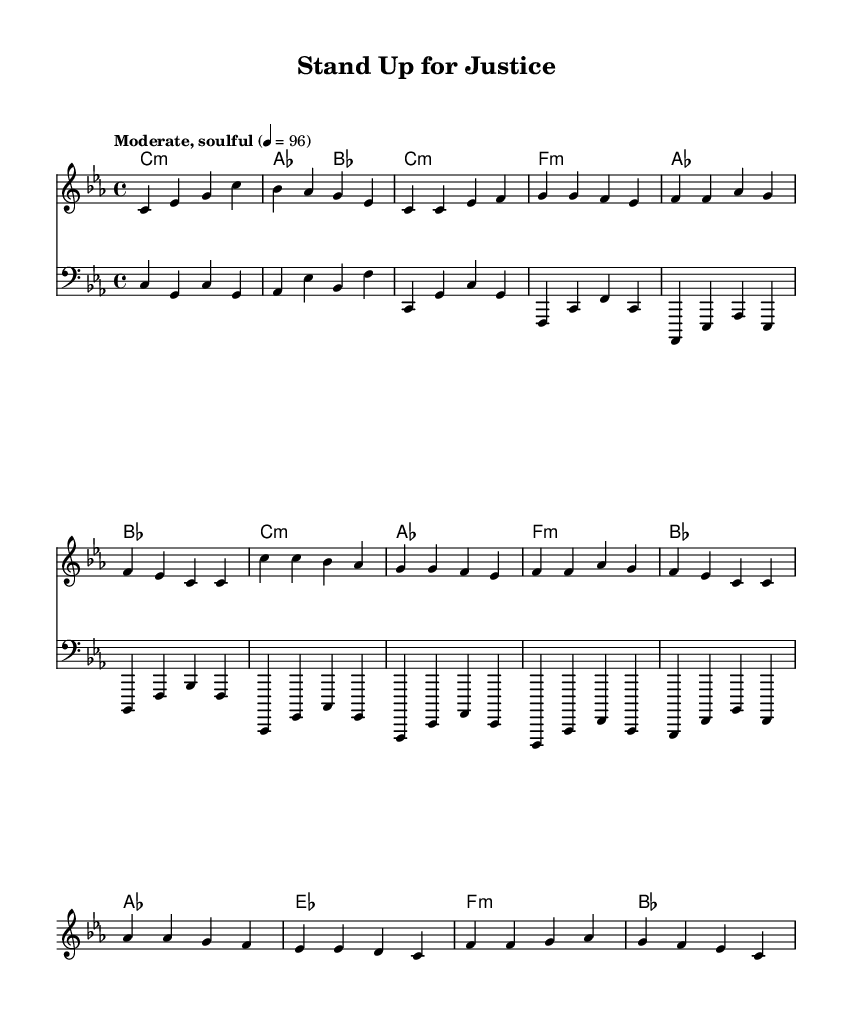What is the key signature of this music? The key signature is C minor, which has three flats (B♭, E♭, and A♭). This can be identified by the 'C' at the beginning of the 'global' section, followed by 'minor,' indicating the specific key.
Answer: C minor What is the time signature of this music? The time signature is 4/4, which is indicated at the beginning of the 'global' section with the 'time' command. In 4/4 time, there are four beats per measure, and the quarter note gets one beat.
Answer: 4/4 What is the tempo marking for this piece? The tempo marking is "Moderate, soulful," which is mentioned in the 'global' section, providing insight into the intended character and pace of the performance.
Answer: Moderate, soulful How many measures are in the verse? The verse consists of 8 measures, which can be counted by looking at the sections in the 'melody' part where the verse lyrics are set and separating them by bars.
Answer: 8 What is the main message conveyed in the chorus? The main message in the chorus is about standing up for justice and making one's voice heard. This can be inferred from the repeated phrases in the chorus lyrics, emphasizing action and collective effort.
Answer: Stand up for justice Which section has a different chord progression, the verse or the chorus? The chorus has a different chord progression compared to the verse. By comparing the chord sequences in the 'harmonies' section for both the verse and the chorus, it’s clear that they differ in their structure and resolve.
Answer: Chorus What type of musical style does this piece exemplify? This piece exemplifies Soul music, characterized by its expressive lyrics related to social issues, rhythm, and grooves that reflect the cultural and emotional significance during the 1970s.
Answer: Soul 